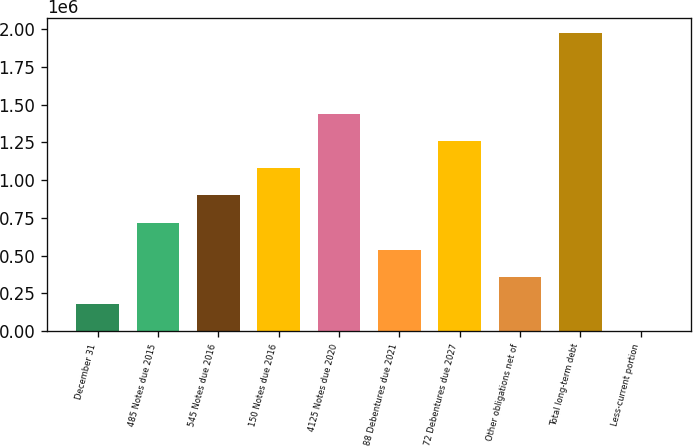<chart> <loc_0><loc_0><loc_500><loc_500><bar_chart><fcel>December 31<fcel>485 Notes due 2015<fcel>545 Notes due 2016<fcel>150 Notes due 2016<fcel>4125 Notes due 2020<fcel>88 Debentures due 2021<fcel>72 Debentures due 2027<fcel>Other obligations net of<fcel>Total long-term debt<fcel>Less-current portion<nl><fcel>180428<fcel>718971<fcel>898485<fcel>1.078e+06<fcel>1.43703e+06<fcel>539457<fcel>1.25751e+06<fcel>359942<fcel>1.97466e+06<fcel>914<nl></chart> 